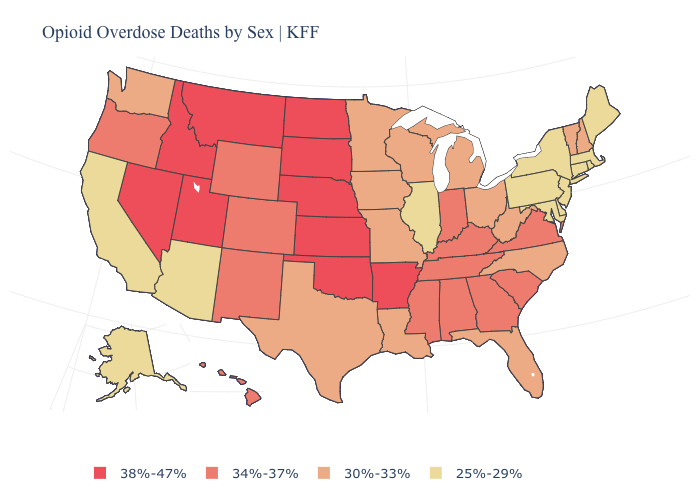Does Mississippi have the same value as Arizona?
Keep it brief. No. Name the states that have a value in the range 25%-29%?
Concise answer only. Alaska, Arizona, California, Connecticut, Delaware, Illinois, Maine, Maryland, Massachusetts, New Jersey, New York, Pennsylvania, Rhode Island. Among the states that border Colorado , does Nebraska have the lowest value?
Be succinct. No. Which states have the lowest value in the West?
Be succinct. Alaska, Arizona, California. Does the map have missing data?
Quick response, please. No. What is the value of Iowa?
Short answer required. 30%-33%. Name the states that have a value in the range 38%-47%?
Give a very brief answer. Arkansas, Idaho, Kansas, Montana, Nebraska, Nevada, North Dakota, Oklahoma, South Dakota, Utah. Name the states that have a value in the range 25%-29%?
Answer briefly. Alaska, Arizona, California, Connecticut, Delaware, Illinois, Maine, Maryland, Massachusetts, New Jersey, New York, Pennsylvania, Rhode Island. Does New Jersey have the lowest value in the USA?
Be succinct. Yes. What is the lowest value in the USA?
Short answer required. 25%-29%. What is the highest value in the South ?
Short answer required. 38%-47%. Does the map have missing data?
Write a very short answer. No. What is the lowest value in states that border Kansas?
Be succinct. 30%-33%. What is the lowest value in the USA?
Concise answer only. 25%-29%. What is the lowest value in the Northeast?
Give a very brief answer. 25%-29%. 